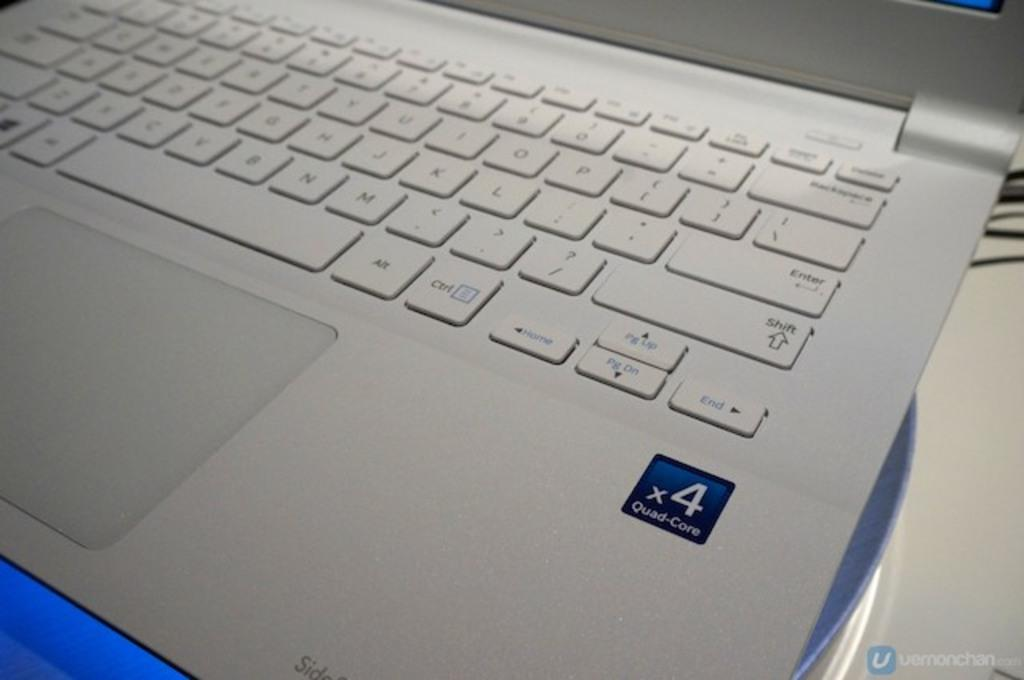<image>
Write a terse but informative summary of the picture. A laptop keyboard shows that the laptop has X4 Quad core ability. 